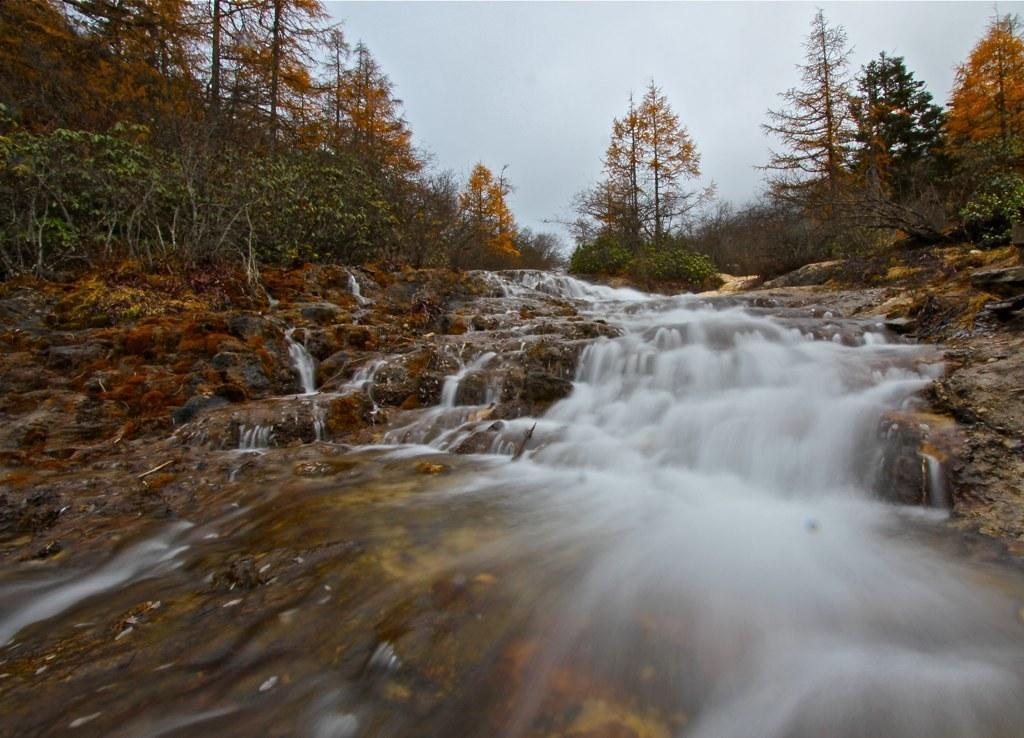What is the primary element that is flowing in the image? There is water flowing in the image. What type of vegetation can be seen in the image? There are trees and plants in the image. What part of the natural environment is visible in the image? The sky is visible in the image. What type of instrument is being played by the tree in the image? There is no tree playing an instrument in the image; trees are not capable of playing instruments. 